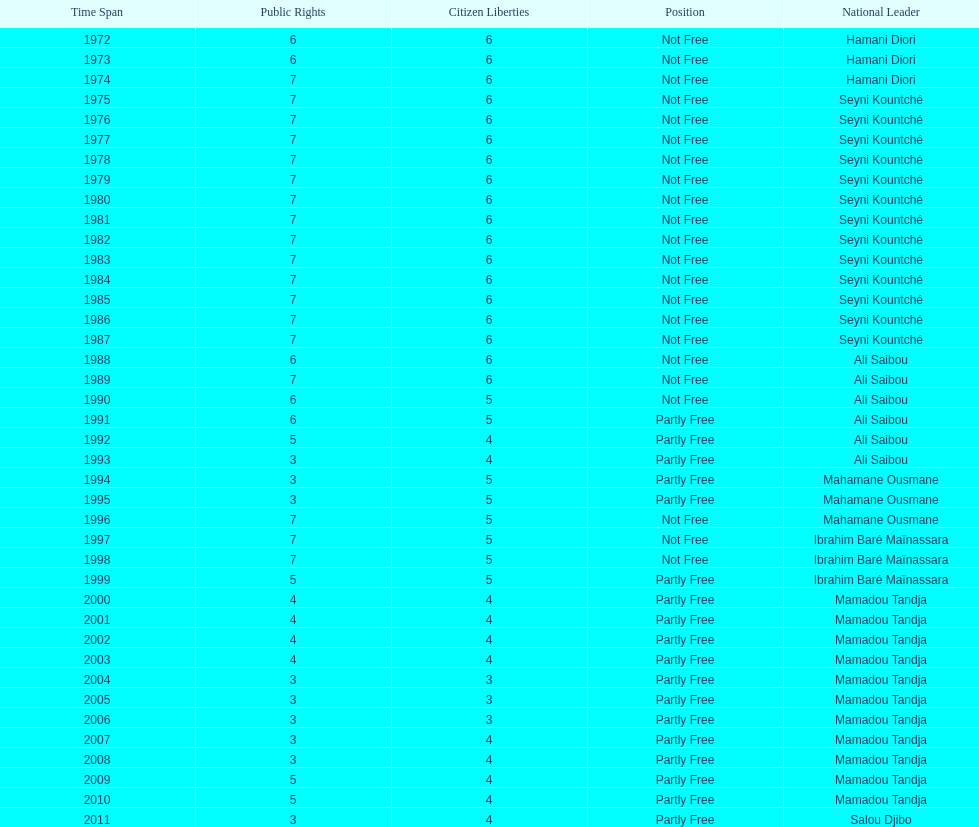Who is the next president listed after hamani diori in the year 1974? Seyni Kountché. 